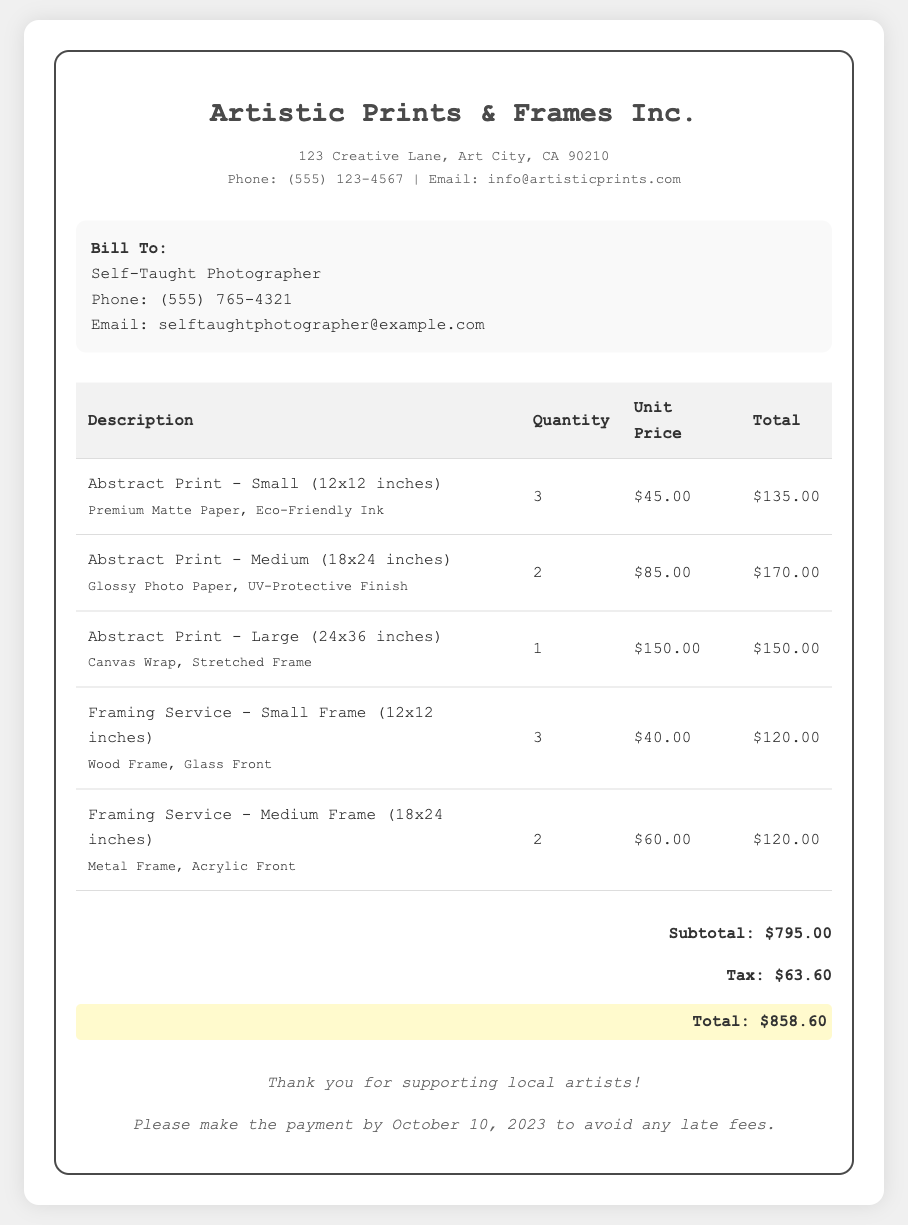what is the total amount due? The total amount due is shown at the bottom of the bill after the subtotal and tax calculations.
Answer: $858.60 how many small abstract prints were ordered? The quantity of small abstract prints is found in the description section of the bill.
Answer: 3 what is the unit price of a medium abstract print? The unit price for a medium abstract print is listed next to the respective item description in the table.
Answer: $85.00 what type of frame was used for the medium framing service? The type of frame used for the medium framing service is specified in the description next to the quantity.
Answer: Metal Frame what is the subtotal before tax? The subtotal is provided in the total section of the bill before the tax is added.
Answer: $795.00 how many large abstract prints were ordered? The quantity of large abstract prints is evident in the table detailing the order.
Answer: 1 when is the payment due? The payment due date is indicated in the footer section of the bill.
Answer: October 10, 2023 what is the tax amount? The tax amount is shown in the total section of the bill and is calculated based on the subtotal.
Answer: $63.60 which company issued this bill? The name of the company that issued the bill is stated at the top of the document.
Answer: Artistic Prints & Frames Inc 